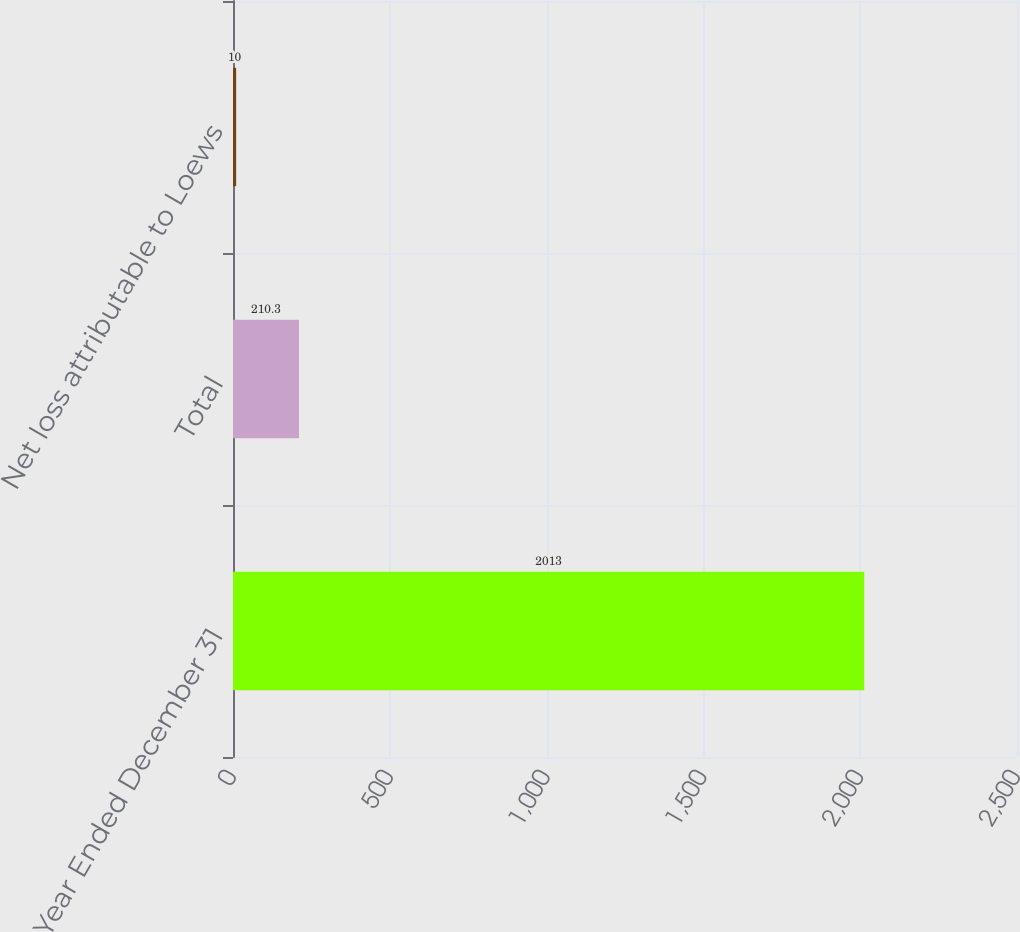Convert chart. <chart><loc_0><loc_0><loc_500><loc_500><bar_chart><fcel>Year Ended December 31<fcel>Total<fcel>Net loss attributable to Loews<nl><fcel>2013<fcel>210.3<fcel>10<nl></chart> 